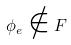Convert formula to latex. <formula><loc_0><loc_0><loc_500><loc_500>\phi _ { e } \notin F</formula> 